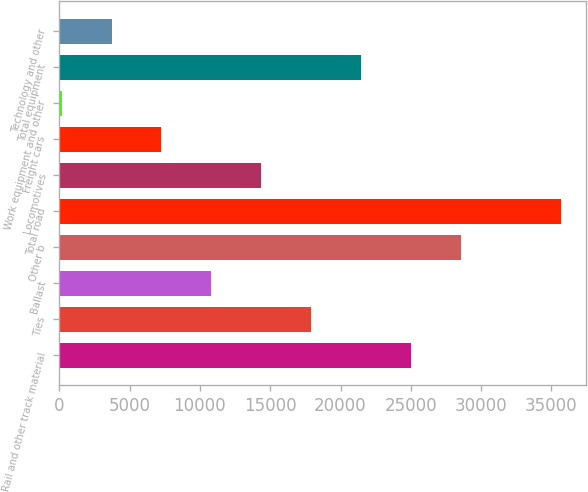Convert chart to OTSL. <chart><loc_0><loc_0><loc_500><loc_500><bar_chart><fcel>Rail and other track material<fcel>Ties<fcel>Ballast<fcel>Other b<fcel>Total road<fcel>Locomotives<fcel>Freight cars<fcel>Work equipment and other<fcel>Total equipment<fcel>Technology and other<nl><fcel>25017.3<fcel>17917.5<fcel>10817.7<fcel>28567.2<fcel>35667<fcel>14367.6<fcel>7267.8<fcel>168<fcel>21467.4<fcel>3717.9<nl></chart> 